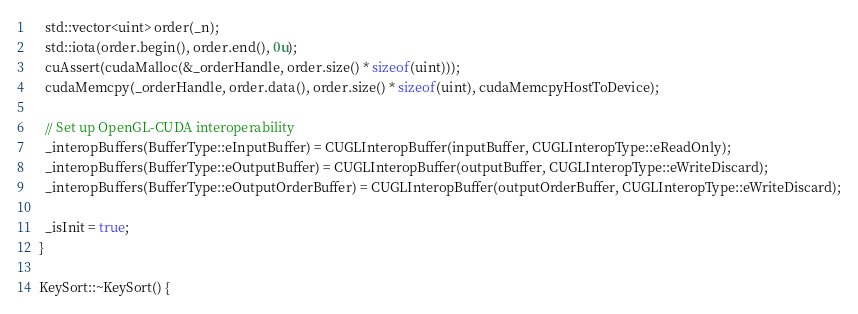<code> <loc_0><loc_0><loc_500><loc_500><_Cuda_>    std::vector<uint> order(_n);
    std::iota(order.begin(), order.end(), 0u);
    cuAssert(cudaMalloc(&_orderHandle, order.size() * sizeof(uint)));
    cudaMemcpy(_orderHandle, order.data(), order.size() * sizeof(uint), cudaMemcpyHostToDevice);

    // Set up OpenGL-CUDA interoperability
    _interopBuffers(BufferType::eInputBuffer) = CUGLInteropBuffer(inputBuffer, CUGLInteropType::eReadOnly);
    _interopBuffers(BufferType::eOutputBuffer) = CUGLInteropBuffer(outputBuffer, CUGLInteropType::eWriteDiscard);
    _interopBuffers(BufferType::eOutputOrderBuffer) = CUGLInteropBuffer(outputOrderBuffer, CUGLInteropType::eWriteDiscard);

    _isInit = true;
  }

  KeySort::~KeySort() {</code> 